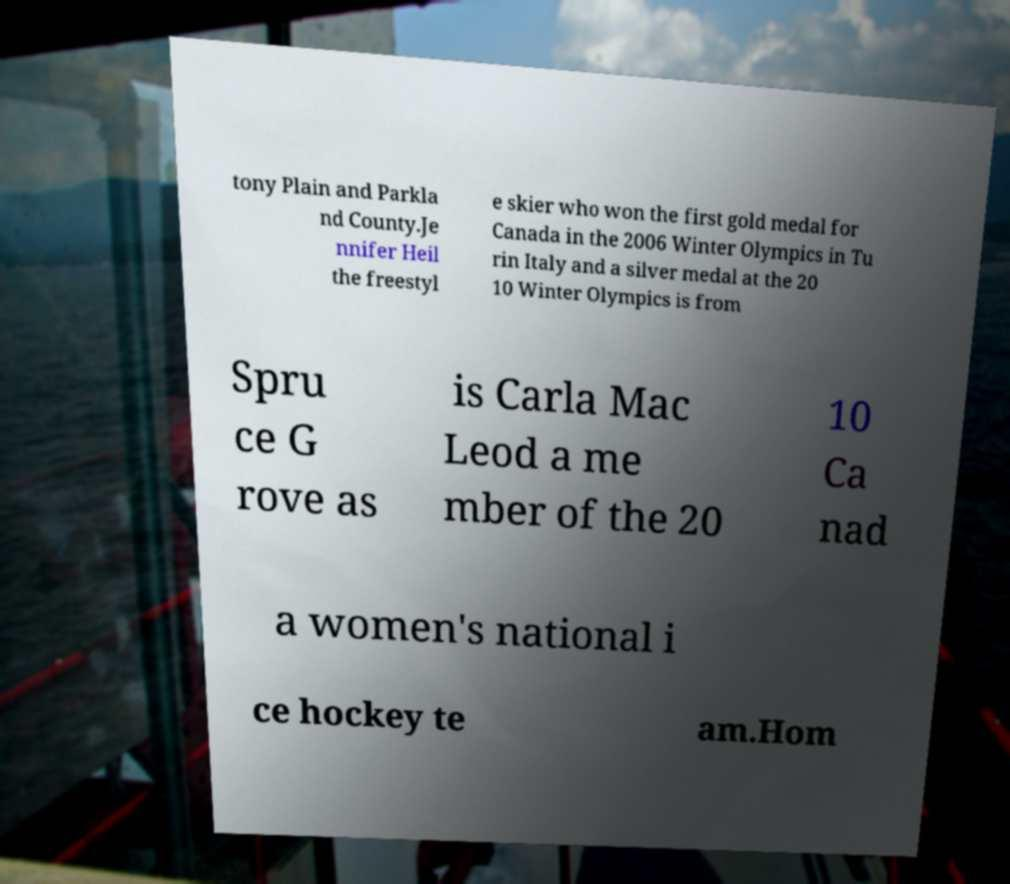Can you read and provide the text displayed in the image?This photo seems to have some interesting text. Can you extract and type it out for me? tony Plain and Parkla nd County.Je nnifer Heil the freestyl e skier who won the first gold medal for Canada in the 2006 Winter Olympics in Tu rin Italy and a silver medal at the 20 10 Winter Olympics is from Spru ce G rove as is Carla Mac Leod a me mber of the 20 10 Ca nad a women's national i ce hockey te am.Hom 